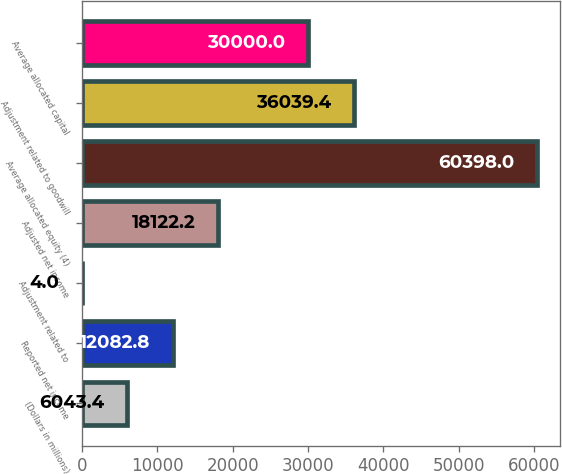Convert chart. <chart><loc_0><loc_0><loc_500><loc_500><bar_chart><fcel>(Dollars in millions)<fcel>Reported net income<fcel>Adjustment related to<fcel>Adjusted net income<fcel>Average allocated equity (4)<fcel>Adjustment related to goodwill<fcel>Average allocated capital<nl><fcel>6043.4<fcel>12082.8<fcel>4<fcel>18122.2<fcel>60398<fcel>36039.4<fcel>30000<nl></chart> 